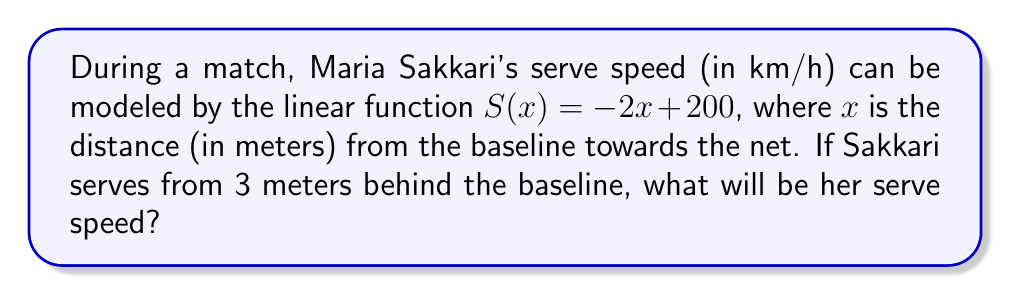Can you solve this math problem? Let's approach this step-by-step:

1) We're given the linear function $S(x) = -2x + 200$, where:
   $S(x)$ is the serve speed in km/h
   $x$ is the distance in meters from the baseline towards the net

2) The baseline is our reference point (x = 0). Serving from behind the baseline means we need to use a negative x-value.

3) Sakkari is serving from 3 meters behind the baseline, so x = -3

4) Let's substitute x = -3 into our function:

   $S(-3) = -2(-3) + 200$

5) Simplify:
   $S(-3) = 6 + 200 = 206$

Therefore, when serving from 3 meters behind the baseline, Sakkari's serve speed will be 206 km/h.
Answer: 206 km/h 